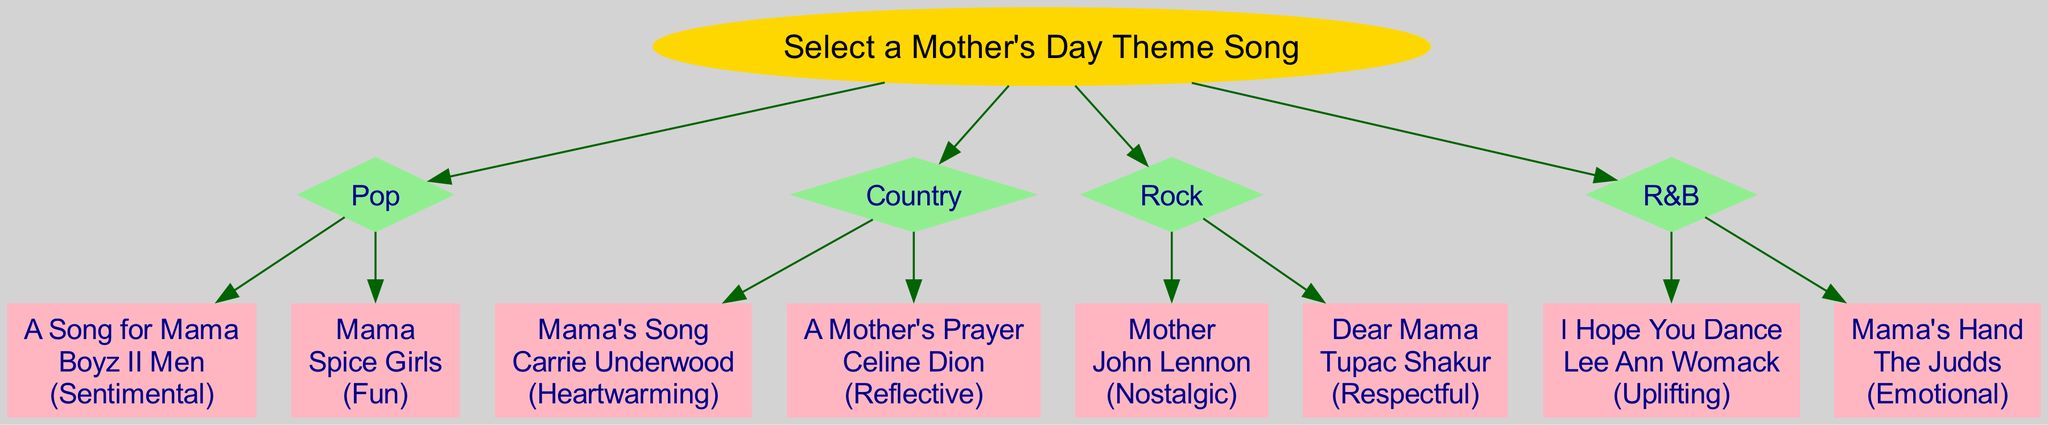what is the title of a Pop song in the diagram? The diagram lists two Pop songs: "A Song for Mama" and "Mama." Both titles are under the Pop genre, so either could be an answer.
Answer: A Song for Mama how many total genres are represented in the diagram? The diagram presents four distinct genres, listed as Pop, Country, Rock, and R&B. This count is obtained by simply looking at the genre branches stemming from the root node.
Answer: 4 which song in the Country genre has an emotional mood? In the Country genre, "A Mother's Prayer" by Celine Dion is listed as having a Reflective mood, while "Mama's Song" has a Heartwarming mood. None are specifically emotional, but if looking for emotional themes, "Mama's Song" could fit.
Answer: Mama's Song what mood is associated with “Dear Mama” by Tupac Shakur? The diagram indicates that "Dear Mama" falls under the Rock genre and is associated with a Respectful mood. I find this by tracing the song back to its genre node.
Answer: Respectful which genre contains the song “I Hope You Dance”? According to the diagram, "I Hope You Dance" is categorized within the R&B genre as outlined in the respective branch stemming from the root.
Answer: R&B how many songs are listed under the Rock genre? The diagram shows that there are two songs under the Rock genre: "Mother" by John Lennon and "Dear Mama" by Tupac Shakur. Counting the song cards under the Rock branch confirms this number.
Answer: 2 which genre has the highest level of sentiment based on its songs' moods? The Pop genre has songs with Sentimental and Fun moods, which can be perceived as high in sentiment. The Country genre's songs are Heartwarming and Reflective, which are also sentimental. However, the Pop genre potentially has a broader appeal. The reasoning involves comparing the mood descriptions under each genre.
Answer: Pop which artist is associated with the song “Mama’s Hand”? The song “Mama's Hand” is associated with The Judds, as indicated under the R&B genre section of the diagram, accompanying other songs.
Answer: The Judds which song is categorized as nostalgic in mood? "Mother" by John Lennon is labeled with a Nostalgic mood in the Rock genre, according to the specific details given in the diagram. Thus, the tracing from the genre to the song reveals this classification.
Answer: Mother 